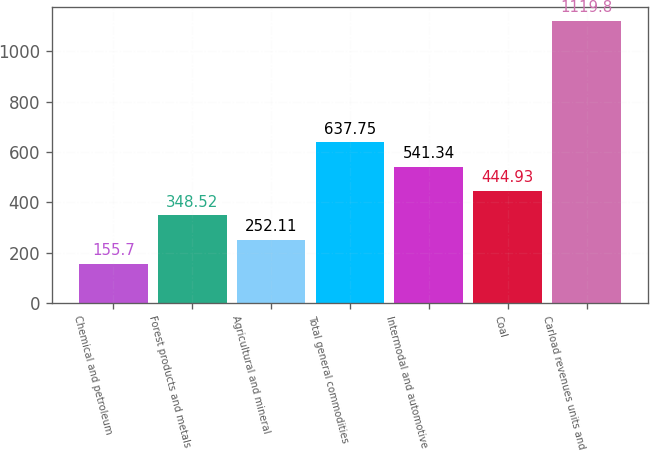Convert chart. <chart><loc_0><loc_0><loc_500><loc_500><bar_chart><fcel>Chemical and petroleum<fcel>Forest products and metals<fcel>Agricultural and mineral<fcel>Total general commodities<fcel>Intermodal and automotive<fcel>Coal<fcel>Carload revenues units and<nl><fcel>155.7<fcel>348.52<fcel>252.11<fcel>637.75<fcel>541.34<fcel>444.93<fcel>1119.8<nl></chart> 